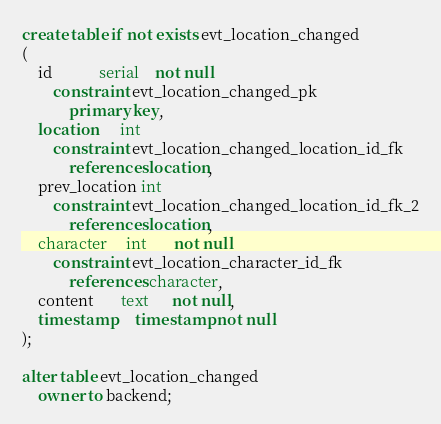<code> <loc_0><loc_0><loc_500><loc_500><_SQL_>create table if not exists evt_location_changed
(
    id            serial    not null
        constraint evt_location_changed_pk
            primary key,
    location      int
        constraint evt_location_changed_location_id_fk
            references location,
    prev_location int
        constraint evt_location_changed_location_id_fk_2
            references location,
    character     int       not null
        constraint evt_location_character_id_fk
            references character,
    content       text      not null,
    timestamp     timestamp not null
);

alter table evt_location_changed
    owner to backend;
</code> 